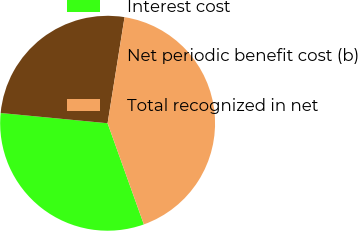Convert chart to OTSL. <chart><loc_0><loc_0><loc_500><loc_500><pie_chart><fcel>Interest cost<fcel>Net periodic benefit cost (b)<fcel>Total recognized in net<nl><fcel>32.0%<fcel>26.0%<fcel>42.0%<nl></chart> 